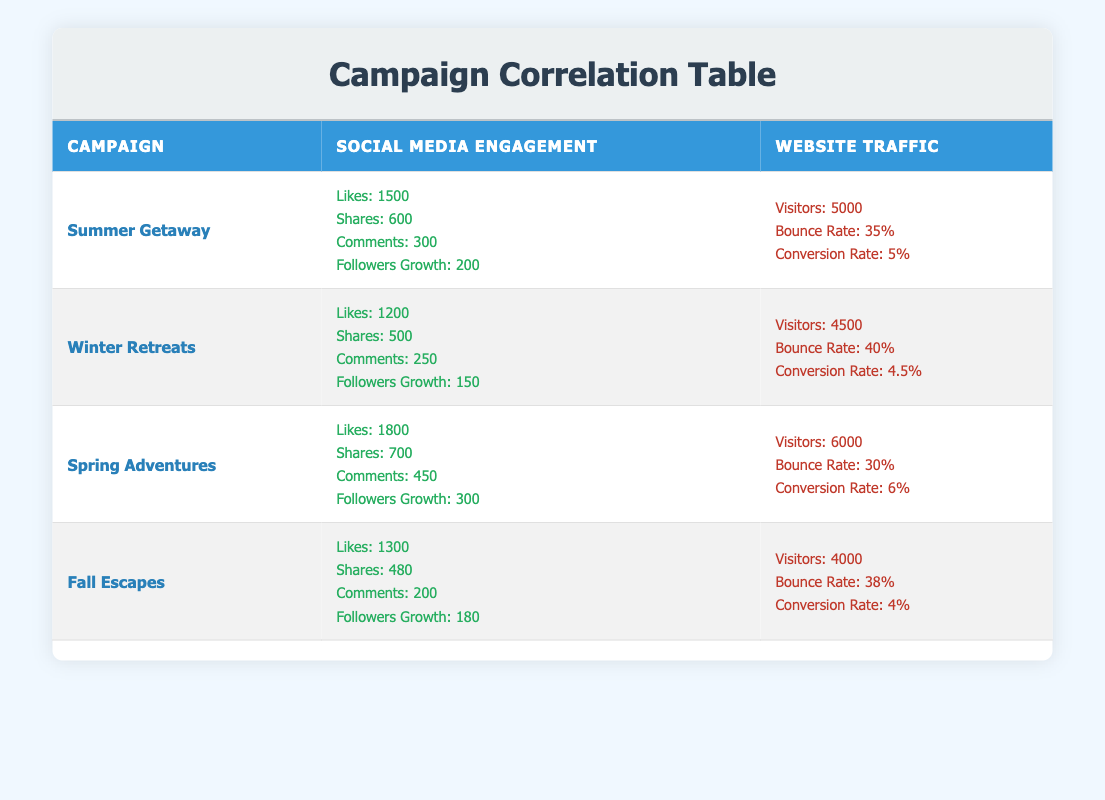What is the highest number of likes recorded across the campaigns? Looking through the "likes" column of the social media engagement, "Spring Adventures" has the highest likes at 1800.
Answer: 1800 What is the total number of visitors across all campaigns? To find the total visitors, we sum the "visitors" for each campaign: 5000 + 4500 + 6000 + 4000 = 19500.
Answer: 19500 Which campaign had the lowest conversion rate? By examining the "conversion rate" column, "Fall Escapes" has the lowest conversion rate at 4%.
Answer: 4% Did the "Winter Retreats" campaign have more shares than the "Fall Escapes"? Comparing shares, "Winter Retreats" recorded 500 shares while "Fall Escapes" recorded 480 shares, so the statement is true.
Answer: Yes What is the average bounce rate across all campaigns? To calculate the average bounce rate, we sum the bounce rates: 35 + 40 + 30 + 38 = 143, and divide by 4 campaigns, resulting in 143/4 = 35.75.
Answer: 35.75 Which campaign had the greatest followers growth? By looking at the "Followers Growth" values, "Spring Adventures" has the greatest followers growth at 300.
Answer: 300 Are there any campaigns with a bounce rate lower than 35%? Checking the bounce rates, none of the campaigns have a bounce rate lower than 35%. The lowest is 30%, which is from "Spring Adventures".
Answer: No What is the difference in visitors between the "Summer Getaway" and "Winter Retreats"? To find the difference, we subtract the visitors of "Winter Retreats" from those of "Summer Getaway": 5000 - 4500 = 500.
Answer: 500 How many total comments were made across all campaigns? We sum the comments: 300 (Summer Getaway) + 250 (Winter Retreats) + 450 (Spring Adventures) + 200 (Fall Escapes) = 1200.
Answer: 1200 